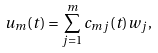<formula> <loc_0><loc_0><loc_500><loc_500>u _ { m } ( t ) = { \sum _ { j = 1 } ^ { m } { c _ { m j } ( t ) w _ { j } } } ,</formula> 